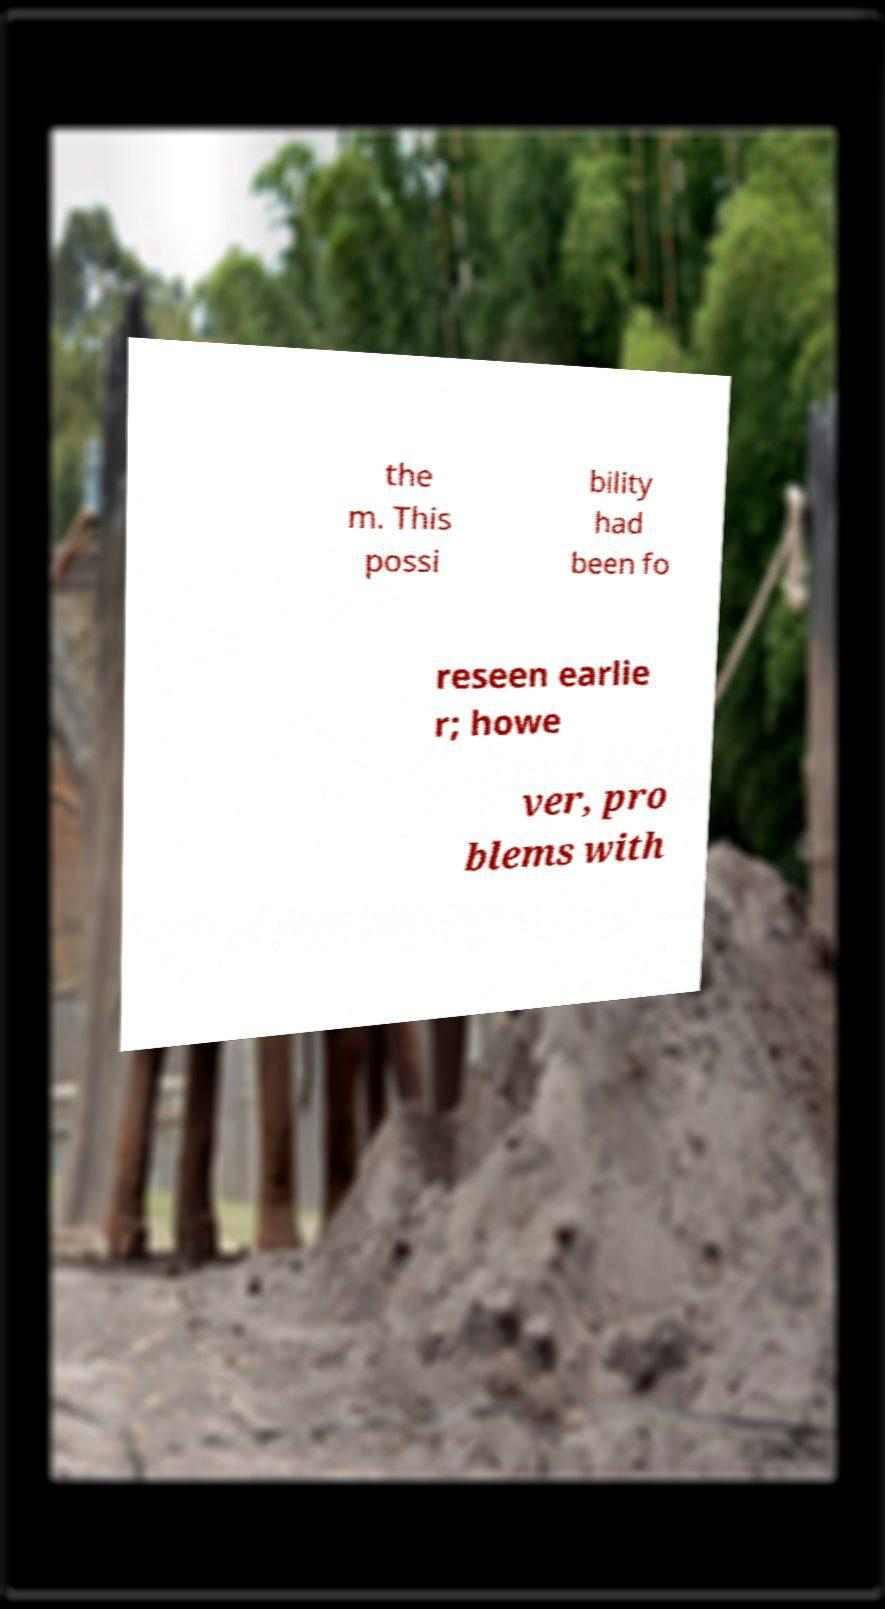I need the written content from this picture converted into text. Can you do that? the m. This possi bility had been fo reseen earlie r; howe ver, pro blems with 